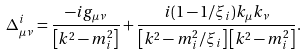<formula> <loc_0><loc_0><loc_500><loc_500>\Delta ^ { i } _ { \mu \nu } = \frac { - i g _ { \mu \nu } } { \left [ k ^ { 2 } - m _ { i } ^ { 2 } \right ] } + \frac { i ( 1 - 1 / \xi _ { i } ) k _ { \mu } k _ { \nu } } { \left [ k ^ { 2 } - m _ { i } ^ { 2 } / \xi _ { i } \right ] \left [ k ^ { 2 } - m _ { i } ^ { 2 } \right ] } .</formula> 